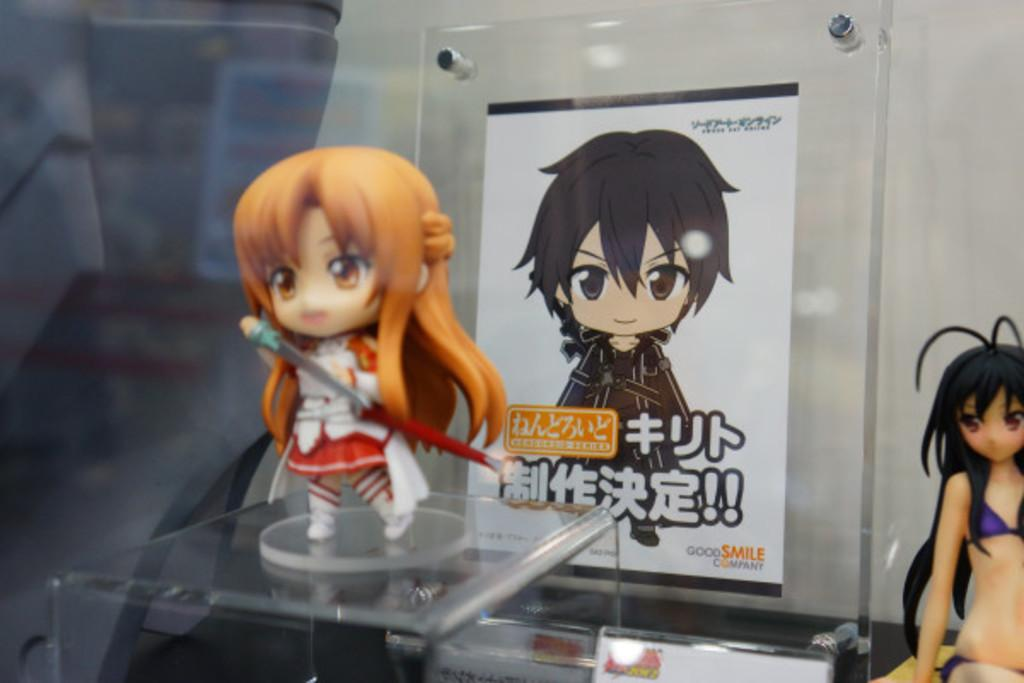What type of currency is visible in the image? There are dollars in the image. What else can be seen in the image besides the currency? There is a poster in the image. What is written on the poster? There is writing on the poster. How would you describe the overall quality of the image? The image is slightly blurry in the background. How many legs are visible in the image? There are no legs visible in the image. What type of feast is being prepared in the image? There is no feast or any food preparation visible in the image. 